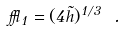<formula> <loc_0><loc_0><loc_500><loc_500>\epsilon _ { 1 } = ( 4 \tilde { h } ) ^ { 1 / 3 } \ .</formula> 